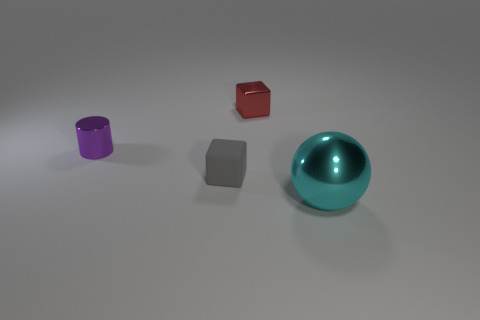Subtract all gray blocks. Subtract all red balls. How many blocks are left? 1 Subtract all blue cylinders. How many blue balls are left? 0 Add 1 grays. How many cyans exist? 0 Subtract all purple cylinders. Subtract all red metallic cubes. How many objects are left? 2 Add 4 gray blocks. How many gray blocks are left? 5 Add 4 tiny purple cylinders. How many tiny purple cylinders exist? 5 Add 2 shiny cubes. How many objects exist? 6 Subtract all red blocks. How many blocks are left? 1 Subtract 1 gray cubes. How many objects are left? 3 Subtract all balls. How many objects are left? 3 